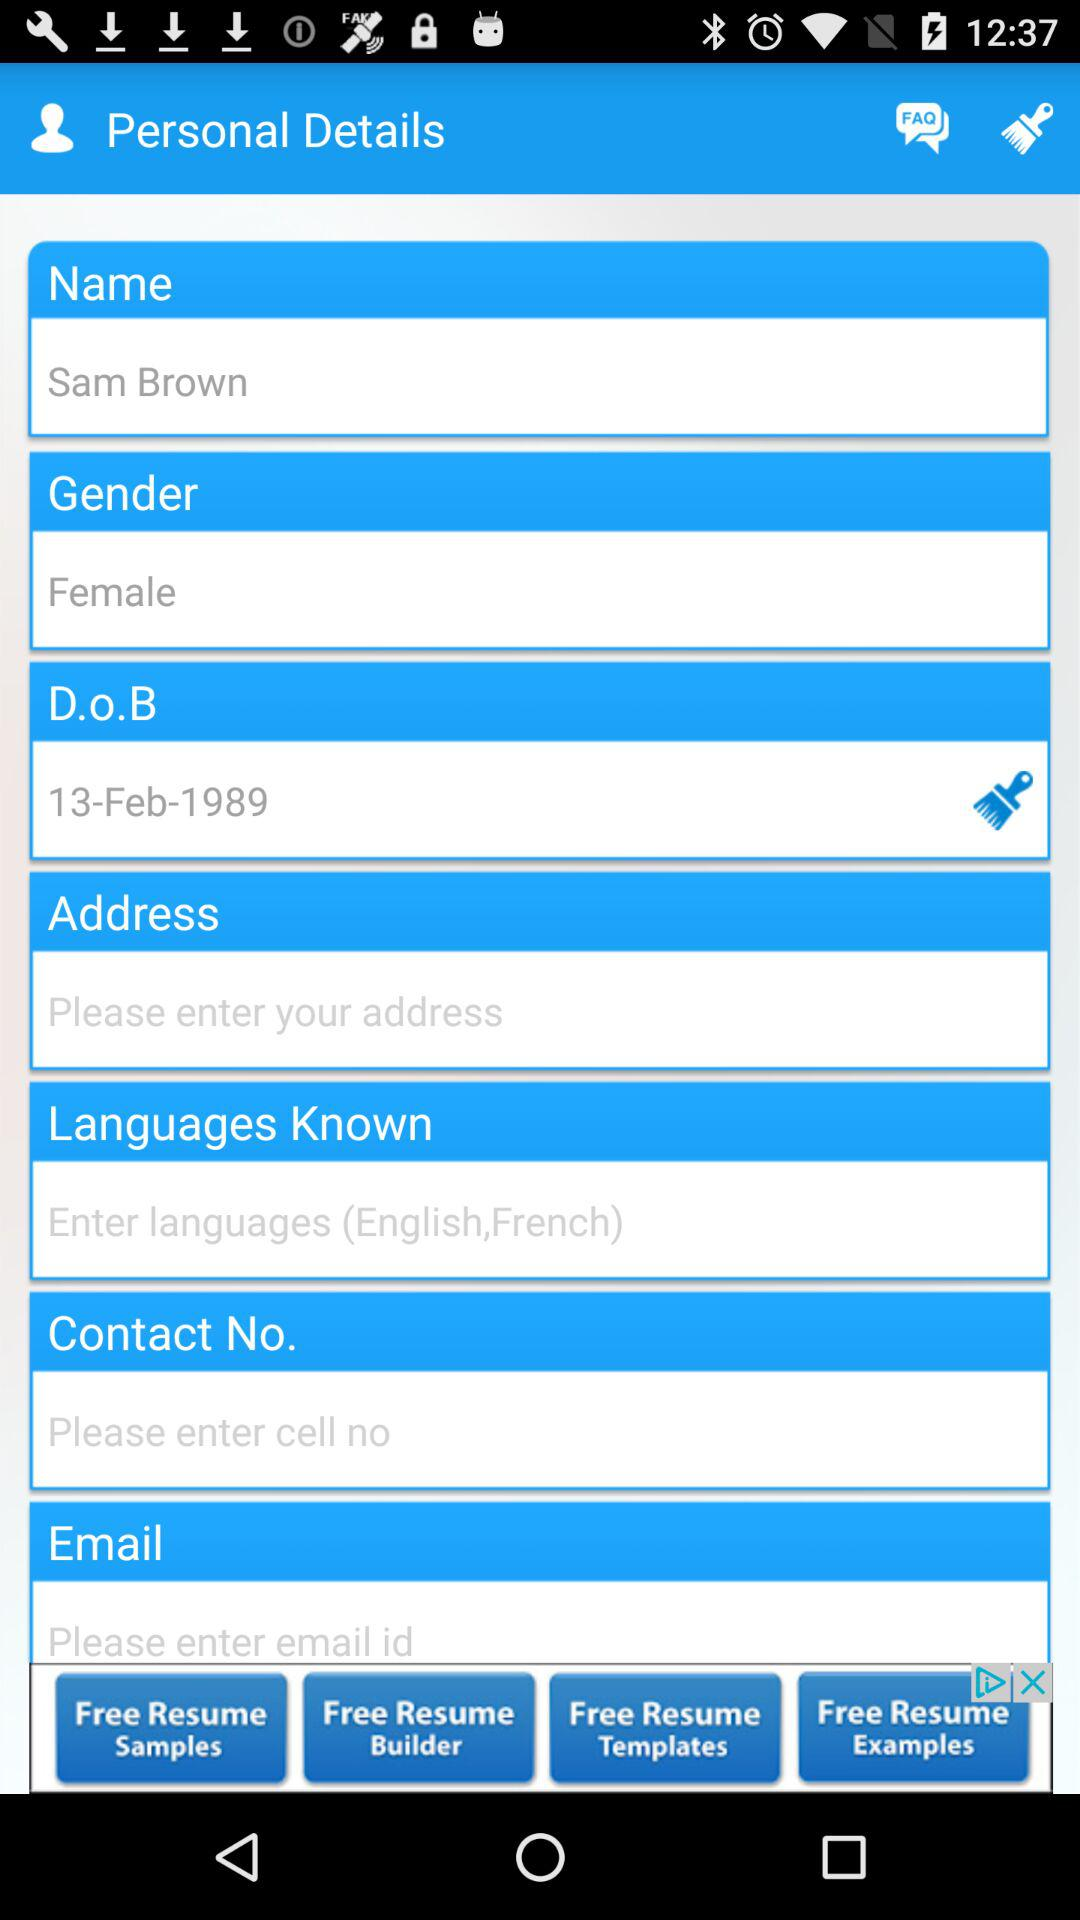What is the gender? The gender is female. 